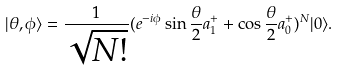<formula> <loc_0><loc_0><loc_500><loc_500>| \theta , \phi \rangle = \frac { 1 } { \sqrt { N ! } } ( e ^ { - i \phi } \sin { \frac { \theta } { 2 } } a _ { 1 } ^ { + } + \cos { \frac { \theta } { 2 } } a _ { 0 } ^ { + } ) ^ { N } | 0 \rangle .</formula> 